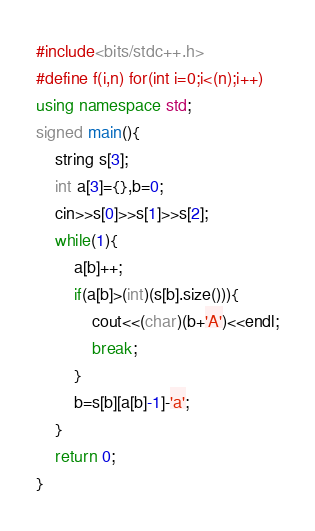<code> <loc_0><loc_0><loc_500><loc_500><_C++_>#include<bits/stdc++.h>
#define f(i,n) for(int i=0;i<(n);i++)
using namespace std;
signed main(){
	string s[3];
	int a[3]={},b=0;
	cin>>s[0]>>s[1]>>s[2];
	while(1){
		a[b]++;
		if(a[b]>(int)(s[b].size())){
			cout<<(char)(b+'A')<<endl;
			break;
		}
		b=s[b][a[b]-1]-'a';
	}
	return 0;
}
</code> 